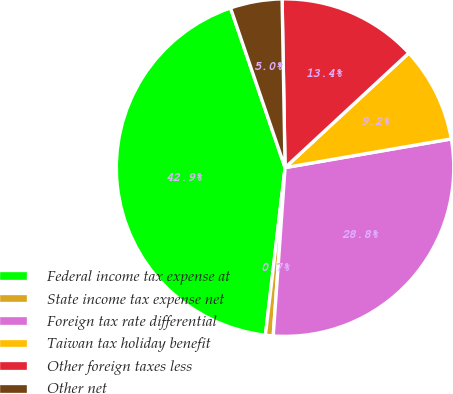Convert chart. <chart><loc_0><loc_0><loc_500><loc_500><pie_chart><fcel>Federal income tax expense at<fcel>State income tax expense net<fcel>Foreign tax rate differential<fcel>Taiwan tax holiday benefit<fcel>Other foreign taxes less<fcel>Other net<nl><fcel>42.9%<fcel>0.74%<fcel>28.84%<fcel>9.17%<fcel>13.39%<fcel>4.96%<nl></chart> 